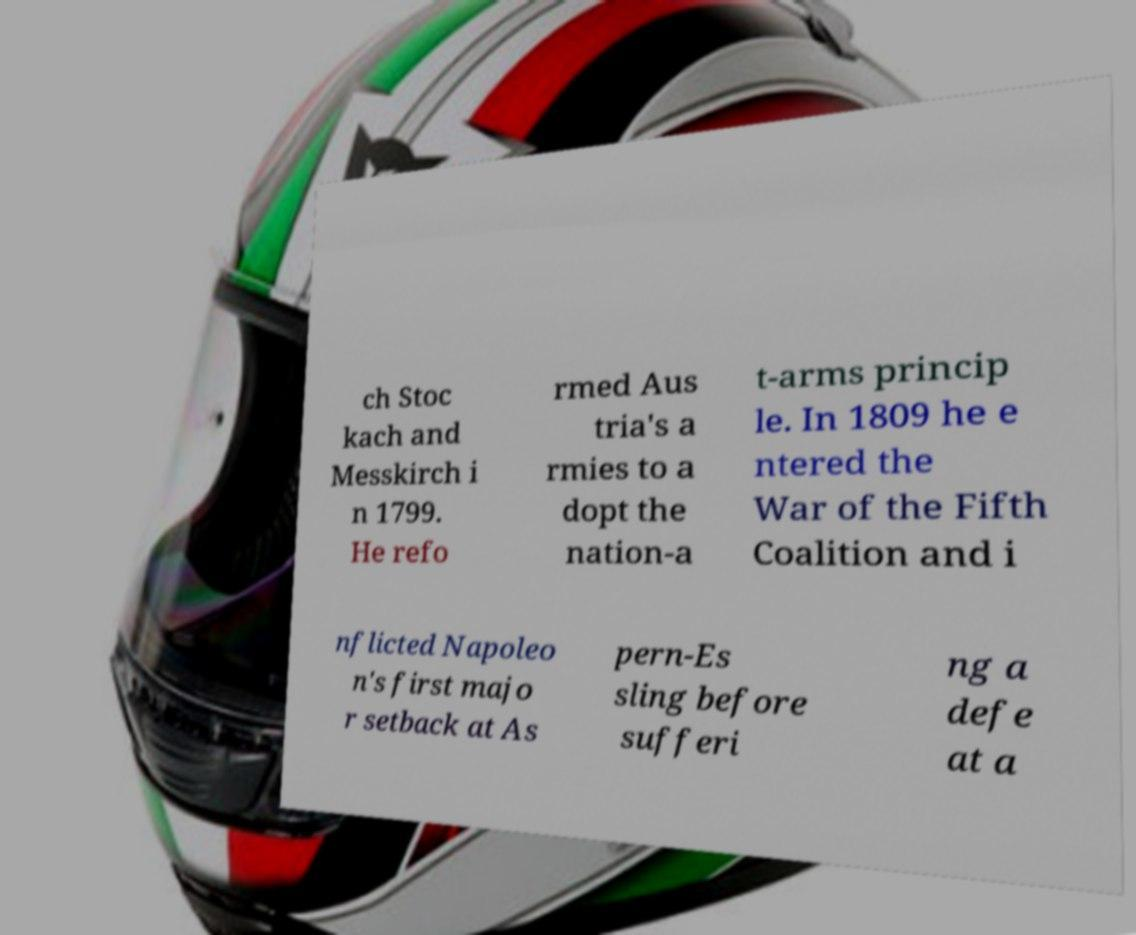There's text embedded in this image that I need extracted. Can you transcribe it verbatim? ch Stoc kach and Messkirch i n 1799. He refo rmed Aus tria's a rmies to a dopt the nation-a t-arms princip le. In 1809 he e ntered the War of the Fifth Coalition and i nflicted Napoleo n's first majo r setback at As pern-Es sling before sufferi ng a defe at a 